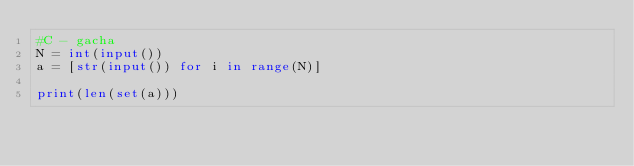Convert code to text. <code><loc_0><loc_0><loc_500><loc_500><_Python_>#C - gacha
N = int(input())
a = [str(input()) for i in range(N)]

print(len(set(a)))</code> 